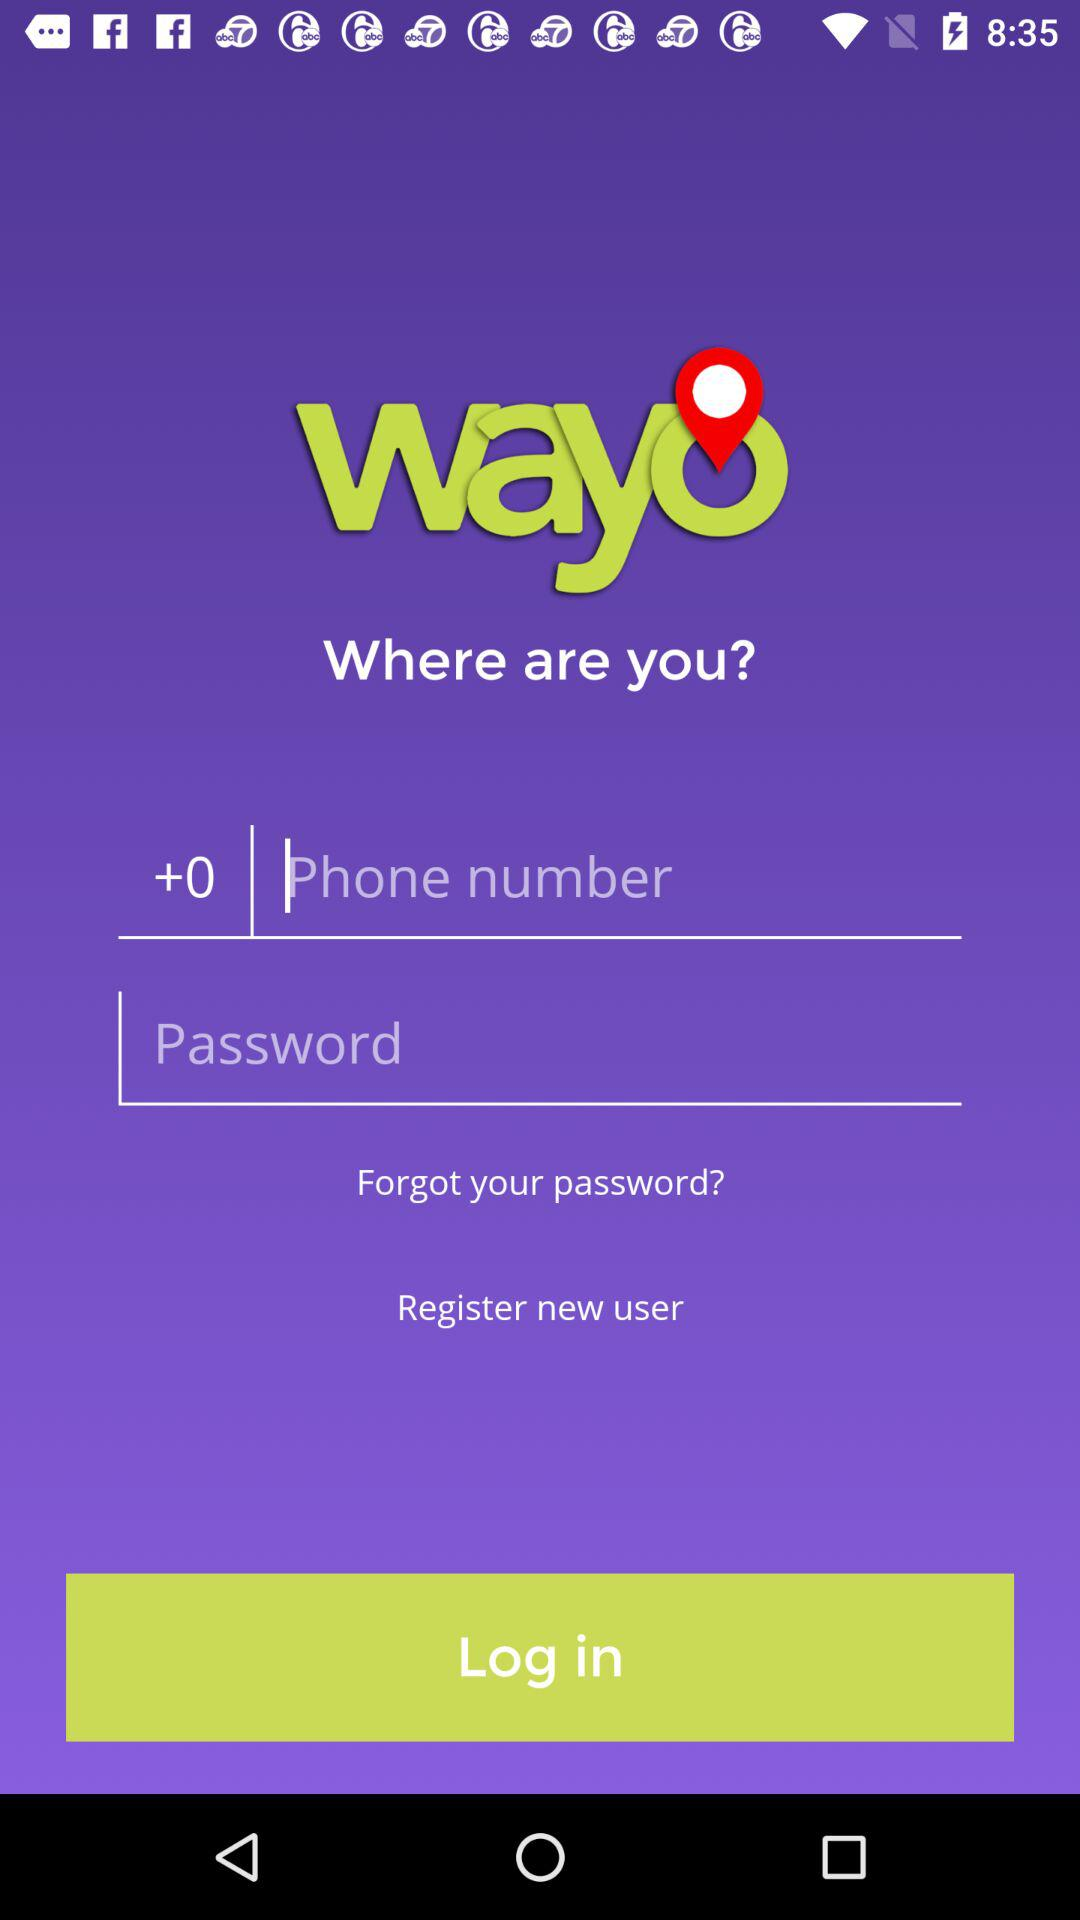What is the application name? The application name is "wayo". 